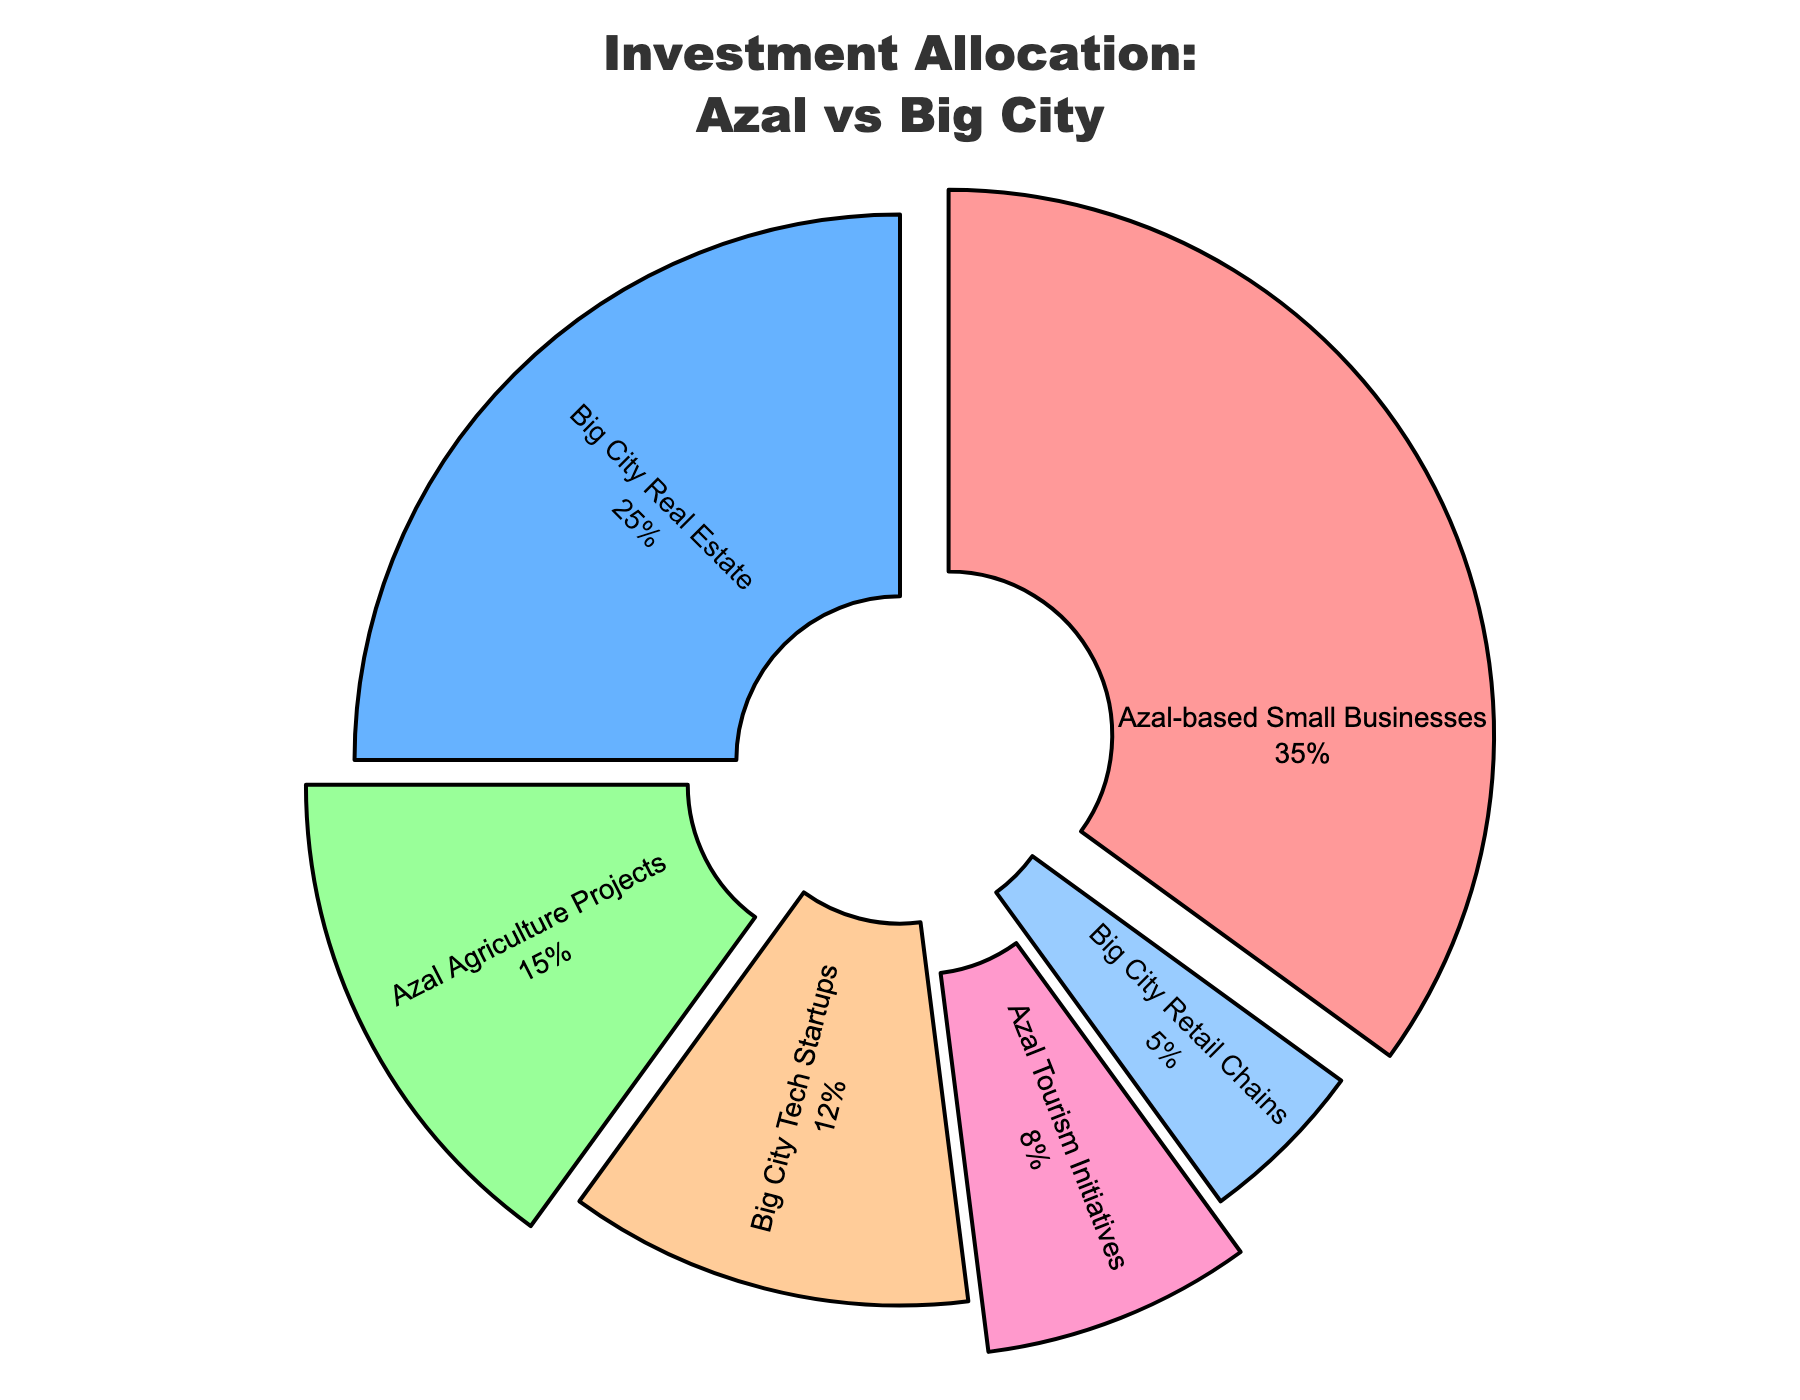Which type of investment has the highest allocation? The type of investment with the highest allocation would have the largest section in the pie chart. In this case, the "Azal-based Small Businesses" has the largest section.
Answer: Azal-based Small Businesses What is the combined percentage of investments based in Azal? The investments based in Azal are "Azal-based Small Businesses" (35%), "Azal Agriculture Projects" (15%), and "Azal Tourism Initiatives" (8%). Adding these percentages together: 35% + 15% + 8% = 58%.
Answer: 58% How does the percentage of investments in Big City Tech Startups compare to Big City Retail Chains? The investment in "Big City Tech Startups" is 12%, and "Big City Retail Chains" is 5%. "Big City Tech Startups" has a higher percentage of investment.
Answer: Big City Tech Startups has a higher percentage If I wanted to balance my investments more evenly, what should be the target percentage for each type? To find an even distribution, divide 100% by 6 (the number of investment types). This calculation gives: 100 / 6 ≈ 16.67%.
Answer: 16.67% What is the difference in allocation between Azal Agriculture Projects and Big City Real Estate? The percentage for "Azal Agriculture Projects" is 15% and for "Big City Real Estate" is 25%. The difference is: 25% - 15% = 10%.
Answer: 10% Which investment type has the smallest allocation, and what is its percentage? The pie chart shows that "Big City Retail Chains" has the smallest segment and its percentage is 5%.
Answer: Big City Retail Chains, 5% What percentage of investments is allocated to sectors outside of Azal? Investments outside Azal are "Big City Real Estate" (25%), "Big City Tech Startups" (12%), and "Big City Retail Chains" (5%). Adding these percentages together: 25% + 12% + 5% = 42%.
Answer: 42% What is the combined allocation for all types of investments that contain the word 'City’? Sum the percentages for "Big City Real Estate" (25%), "Big City Tech Startups" (12%), and "Big City Retail Chains" (5%): 25% + 12% + 5% = 42%.
Answer: 42% 